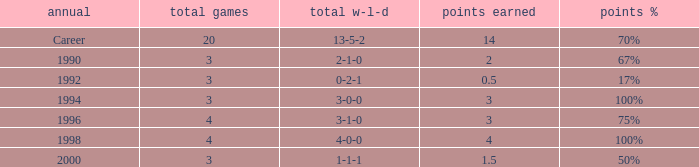Can you tell me the lowest Total natches that has the Points won of 3, and the Year of 1994? 3.0. 